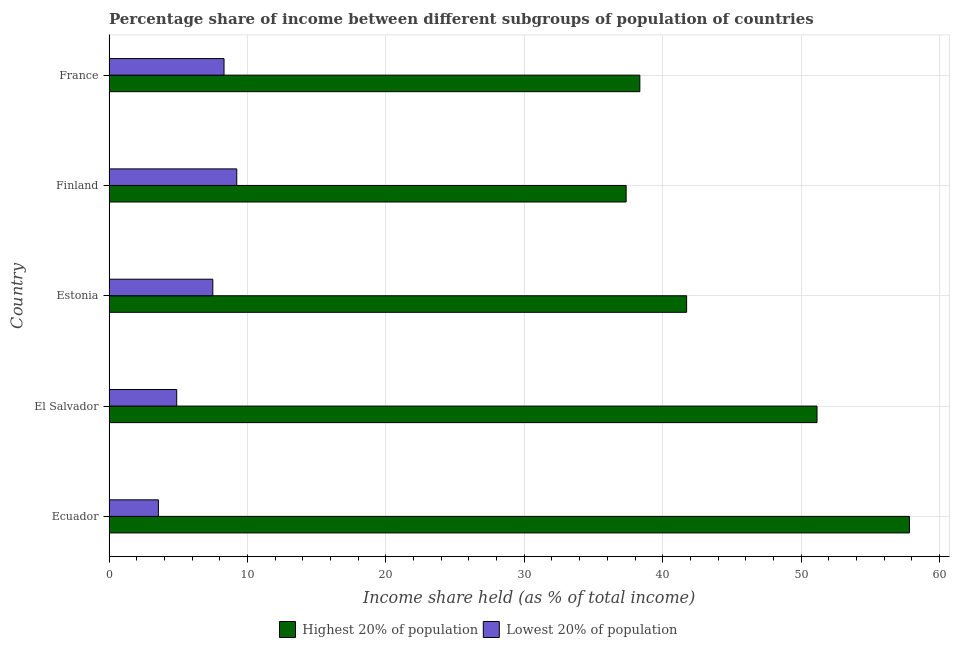Are the number of bars per tick equal to the number of legend labels?
Provide a succinct answer. Yes. Are the number of bars on each tick of the Y-axis equal?
Ensure brevity in your answer.  Yes. How many bars are there on the 5th tick from the bottom?
Keep it short and to the point. 2. What is the label of the 1st group of bars from the top?
Give a very brief answer. France. In how many cases, is the number of bars for a given country not equal to the number of legend labels?
Offer a very short reply. 0. What is the income share held by lowest 20% of the population in Estonia?
Your response must be concise. 7.5. Across all countries, what is the maximum income share held by highest 20% of the population?
Your response must be concise. 57.83. Across all countries, what is the minimum income share held by lowest 20% of the population?
Your answer should be very brief. 3.57. In which country was the income share held by highest 20% of the population maximum?
Offer a very short reply. Ecuador. In which country was the income share held by lowest 20% of the population minimum?
Give a very brief answer. Ecuador. What is the total income share held by highest 20% of the population in the graph?
Your response must be concise. 226.42. What is the difference between the income share held by lowest 20% of the population in Finland and the income share held by highest 20% of the population in France?
Your answer should be compact. -29.12. What is the average income share held by lowest 20% of the population per country?
Offer a terse response. 6.7. What is the difference between the income share held by highest 20% of the population and income share held by lowest 20% of the population in El Salvador?
Give a very brief answer. 46.26. What is the ratio of the income share held by highest 20% of the population in Ecuador to that in Finland?
Keep it short and to the point. 1.55. Is the income share held by lowest 20% of the population in Ecuador less than that in France?
Keep it short and to the point. Yes. What is the difference between the highest and the second highest income share held by highest 20% of the population?
Give a very brief answer. 6.68. What is the difference between the highest and the lowest income share held by highest 20% of the population?
Ensure brevity in your answer.  20.47. In how many countries, is the income share held by highest 20% of the population greater than the average income share held by highest 20% of the population taken over all countries?
Make the answer very short. 2. What does the 2nd bar from the top in Finland represents?
Give a very brief answer. Highest 20% of population. What does the 1st bar from the bottom in Estonia represents?
Give a very brief answer. Highest 20% of population. How many countries are there in the graph?
Your answer should be compact. 5. What is the difference between two consecutive major ticks on the X-axis?
Make the answer very short. 10. Does the graph contain grids?
Your answer should be very brief. Yes. How many legend labels are there?
Your answer should be compact. 2. What is the title of the graph?
Give a very brief answer. Percentage share of income between different subgroups of population of countries. Does "Working capital" appear as one of the legend labels in the graph?
Your response must be concise. No. What is the label or title of the X-axis?
Your answer should be compact. Income share held (as % of total income). What is the Income share held (as % of total income) in Highest 20% of population in Ecuador?
Your answer should be very brief. 57.83. What is the Income share held (as % of total income) of Lowest 20% of population in Ecuador?
Provide a succinct answer. 3.57. What is the Income share held (as % of total income) in Highest 20% of population in El Salvador?
Give a very brief answer. 51.15. What is the Income share held (as % of total income) in Lowest 20% of population in El Salvador?
Give a very brief answer. 4.89. What is the Income share held (as % of total income) in Highest 20% of population in Estonia?
Your response must be concise. 41.73. What is the Income share held (as % of total income) of Lowest 20% of population in Estonia?
Offer a terse response. 7.5. What is the Income share held (as % of total income) of Highest 20% of population in Finland?
Provide a succinct answer. 37.36. What is the Income share held (as % of total income) of Lowest 20% of population in Finland?
Offer a very short reply. 9.23. What is the Income share held (as % of total income) in Highest 20% of population in France?
Your response must be concise. 38.35. What is the Income share held (as % of total income) in Lowest 20% of population in France?
Keep it short and to the point. 8.31. Across all countries, what is the maximum Income share held (as % of total income) of Highest 20% of population?
Your answer should be compact. 57.83. Across all countries, what is the maximum Income share held (as % of total income) of Lowest 20% of population?
Provide a short and direct response. 9.23. Across all countries, what is the minimum Income share held (as % of total income) in Highest 20% of population?
Ensure brevity in your answer.  37.36. Across all countries, what is the minimum Income share held (as % of total income) of Lowest 20% of population?
Your answer should be very brief. 3.57. What is the total Income share held (as % of total income) of Highest 20% of population in the graph?
Make the answer very short. 226.42. What is the total Income share held (as % of total income) in Lowest 20% of population in the graph?
Keep it short and to the point. 33.5. What is the difference between the Income share held (as % of total income) in Highest 20% of population in Ecuador and that in El Salvador?
Make the answer very short. 6.68. What is the difference between the Income share held (as % of total income) in Lowest 20% of population in Ecuador and that in El Salvador?
Your response must be concise. -1.32. What is the difference between the Income share held (as % of total income) of Lowest 20% of population in Ecuador and that in Estonia?
Offer a very short reply. -3.93. What is the difference between the Income share held (as % of total income) of Highest 20% of population in Ecuador and that in Finland?
Make the answer very short. 20.47. What is the difference between the Income share held (as % of total income) of Lowest 20% of population in Ecuador and that in Finland?
Give a very brief answer. -5.66. What is the difference between the Income share held (as % of total income) in Highest 20% of population in Ecuador and that in France?
Keep it short and to the point. 19.48. What is the difference between the Income share held (as % of total income) of Lowest 20% of population in Ecuador and that in France?
Your answer should be compact. -4.74. What is the difference between the Income share held (as % of total income) of Highest 20% of population in El Salvador and that in Estonia?
Ensure brevity in your answer.  9.42. What is the difference between the Income share held (as % of total income) in Lowest 20% of population in El Salvador and that in Estonia?
Offer a very short reply. -2.61. What is the difference between the Income share held (as % of total income) in Highest 20% of population in El Salvador and that in Finland?
Make the answer very short. 13.79. What is the difference between the Income share held (as % of total income) of Lowest 20% of population in El Salvador and that in Finland?
Your answer should be compact. -4.34. What is the difference between the Income share held (as % of total income) of Lowest 20% of population in El Salvador and that in France?
Keep it short and to the point. -3.42. What is the difference between the Income share held (as % of total income) of Highest 20% of population in Estonia and that in Finland?
Your response must be concise. 4.37. What is the difference between the Income share held (as % of total income) in Lowest 20% of population in Estonia and that in Finland?
Offer a very short reply. -1.73. What is the difference between the Income share held (as % of total income) in Highest 20% of population in Estonia and that in France?
Keep it short and to the point. 3.38. What is the difference between the Income share held (as % of total income) in Lowest 20% of population in Estonia and that in France?
Provide a succinct answer. -0.81. What is the difference between the Income share held (as % of total income) of Highest 20% of population in Finland and that in France?
Give a very brief answer. -0.99. What is the difference between the Income share held (as % of total income) in Lowest 20% of population in Finland and that in France?
Your answer should be very brief. 0.92. What is the difference between the Income share held (as % of total income) of Highest 20% of population in Ecuador and the Income share held (as % of total income) of Lowest 20% of population in El Salvador?
Provide a short and direct response. 52.94. What is the difference between the Income share held (as % of total income) of Highest 20% of population in Ecuador and the Income share held (as % of total income) of Lowest 20% of population in Estonia?
Your answer should be very brief. 50.33. What is the difference between the Income share held (as % of total income) of Highest 20% of population in Ecuador and the Income share held (as % of total income) of Lowest 20% of population in Finland?
Provide a succinct answer. 48.6. What is the difference between the Income share held (as % of total income) in Highest 20% of population in Ecuador and the Income share held (as % of total income) in Lowest 20% of population in France?
Provide a succinct answer. 49.52. What is the difference between the Income share held (as % of total income) in Highest 20% of population in El Salvador and the Income share held (as % of total income) in Lowest 20% of population in Estonia?
Your answer should be very brief. 43.65. What is the difference between the Income share held (as % of total income) of Highest 20% of population in El Salvador and the Income share held (as % of total income) of Lowest 20% of population in Finland?
Provide a succinct answer. 41.92. What is the difference between the Income share held (as % of total income) in Highest 20% of population in El Salvador and the Income share held (as % of total income) in Lowest 20% of population in France?
Provide a short and direct response. 42.84. What is the difference between the Income share held (as % of total income) of Highest 20% of population in Estonia and the Income share held (as % of total income) of Lowest 20% of population in Finland?
Your answer should be very brief. 32.5. What is the difference between the Income share held (as % of total income) of Highest 20% of population in Estonia and the Income share held (as % of total income) of Lowest 20% of population in France?
Your answer should be compact. 33.42. What is the difference between the Income share held (as % of total income) of Highest 20% of population in Finland and the Income share held (as % of total income) of Lowest 20% of population in France?
Offer a very short reply. 29.05. What is the average Income share held (as % of total income) of Highest 20% of population per country?
Provide a succinct answer. 45.28. What is the difference between the Income share held (as % of total income) of Highest 20% of population and Income share held (as % of total income) of Lowest 20% of population in Ecuador?
Make the answer very short. 54.26. What is the difference between the Income share held (as % of total income) in Highest 20% of population and Income share held (as % of total income) in Lowest 20% of population in El Salvador?
Make the answer very short. 46.26. What is the difference between the Income share held (as % of total income) of Highest 20% of population and Income share held (as % of total income) of Lowest 20% of population in Estonia?
Provide a succinct answer. 34.23. What is the difference between the Income share held (as % of total income) of Highest 20% of population and Income share held (as % of total income) of Lowest 20% of population in Finland?
Your answer should be compact. 28.13. What is the difference between the Income share held (as % of total income) of Highest 20% of population and Income share held (as % of total income) of Lowest 20% of population in France?
Your answer should be very brief. 30.04. What is the ratio of the Income share held (as % of total income) in Highest 20% of population in Ecuador to that in El Salvador?
Ensure brevity in your answer.  1.13. What is the ratio of the Income share held (as % of total income) of Lowest 20% of population in Ecuador to that in El Salvador?
Offer a terse response. 0.73. What is the ratio of the Income share held (as % of total income) of Highest 20% of population in Ecuador to that in Estonia?
Provide a succinct answer. 1.39. What is the ratio of the Income share held (as % of total income) in Lowest 20% of population in Ecuador to that in Estonia?
Keep it short and to the point. 0.48. What is the ratio of the Income share held (as % of total income) in Highest 20% of population in Ecuador to that in Finland?
Provide a short and direct response. 1.55. What is the ratio of the Income share held (as % of total income) in Lowest 20% of population in Ecuador to that in Finland?
Offer a very short reply. 0.39. What is the ratio of the Income share held (as % of total income) of Highest 20% of population in Ecuador to that in France?
Offer a very short reply. 1.51. What is the ratio of the Income share held (as % of total income) of Lowest 20% of population in Ecuador to that in France?
Give a very brief answer. 0.43. What is the ratio of the Income share held (as % of total income) of Highest 20% of population in El Salvador to that in Estonia?
Give a very brief answer. 1.23. What is the ratio of the Income share held (as % of total income) of Lowest 20% of population in El Salvador to that in Estonia?
Offer a very short reply. 0.65. What is the ratio of the Income share held (as % of total income) of Highest 20% of population in El Salvador to that in Finland?
Offer a terse response. 1.37. What is the ratio of the Income share held (as % of total income) in Lowest 20% of population in El Salvador to that in Finland?
Offer a very short reply. 0.53. What is the ratio of the Income share held (as % of total income) of Highest 20% of population in El Salvador to that in France?
Provide a short and direct response. 1.33. What is the ratio of the Income share held (as % of total income) in Lowest 20% of population in El Salvador to that in France?
Ensure brevity in your answer.  0.59. What is the ratio of the Income share held (as % of total income) of Highest 20% of population in Estonia to that in Finland?
Offer a terse response. 1.12. What is the ratio of the Income share held (as % of total income) in Lowest 20% of population in Estonia to that in Finland?
Make the answer very short. 0.81. What is the ratio of the Income share held (as % of total income) in Highest 20% of population in Estonia to that in France?
Provide a succinct answer. 1.09. What is the ratio of the Income share held (as % of total income) of Lowest 20% of population in Estonia to that in France?
Your response must be concise. 0.9. What is the ratio of the Income share held (as % of total income) of Highest 20% of population in Finland to that in France?
Your response must be concise. 0.97. What is the ratio of the Income share held (as % of total income) in Lowest 20% of population in Finland to that in France?
Your response must be concise. 1.11. What is the difference between the highest and the second highest Income share held (as % of total income) in Highest 20% of population?
Make the answer very short. 6.68. What is the difference between the highest and the second highest Income share held (as % of total income) in Lowest 20% of population?
Ensure brevity in your answer.  0.92. What is the difference between the highest and the lowest Income share held (as % of total income) in Highest 20% of population?
Give a very brief answer. 20.47. What is the difference between the highest and the lowest Income share held (as % of total income) in Lowest 20% of population?
Your answer should be very brief. 5.66. 